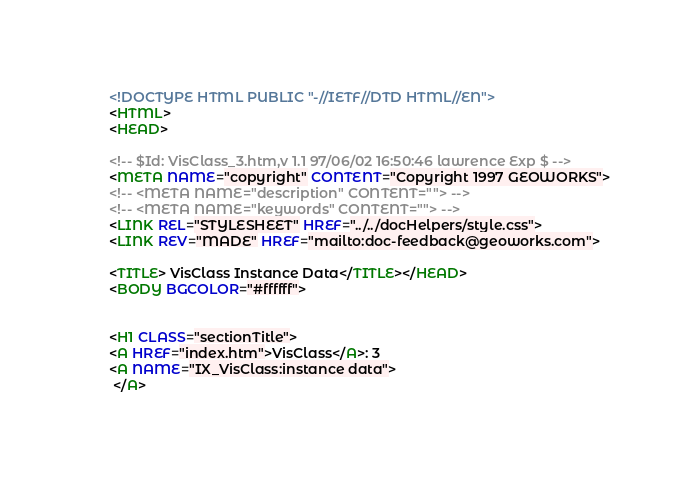Convert code to text. <code><loc_0><loc_0><loc_500><loc_500><_HTML_><!DOCTYPE HTML PUBLIC "-//IETF//DTD HTML//EN">
<HTML>
<HEAD>

<!-- $Id: VisClass_3.htm,v 1.1 97/06/02 16:50:46 lawrence Exp $ -->
<META NAME="copyright" CONTENT="Copyright 1997 GEOWORKS">
<!-- <META NAME="description" CONTENT=""> -->
<!-- <META NAME="keywords" CONTENT=""> -->
<LINK REL="STYLESHEET" HREF="../../docHelpers/style.css">
<LINK REV="MADE" HREF="mailto:doc-feedback@geoworks.com">

<TITLE> VisClass Instance Data</TITLE></HEAD>
<BODY BGCOLOR="#ffffff">


<H1 CLASS="sectionTitle">
<A HREF="index.htm">VisClass</A>: 3 
<A NAME="IX_VisClass:instance data">
 </A></code> 